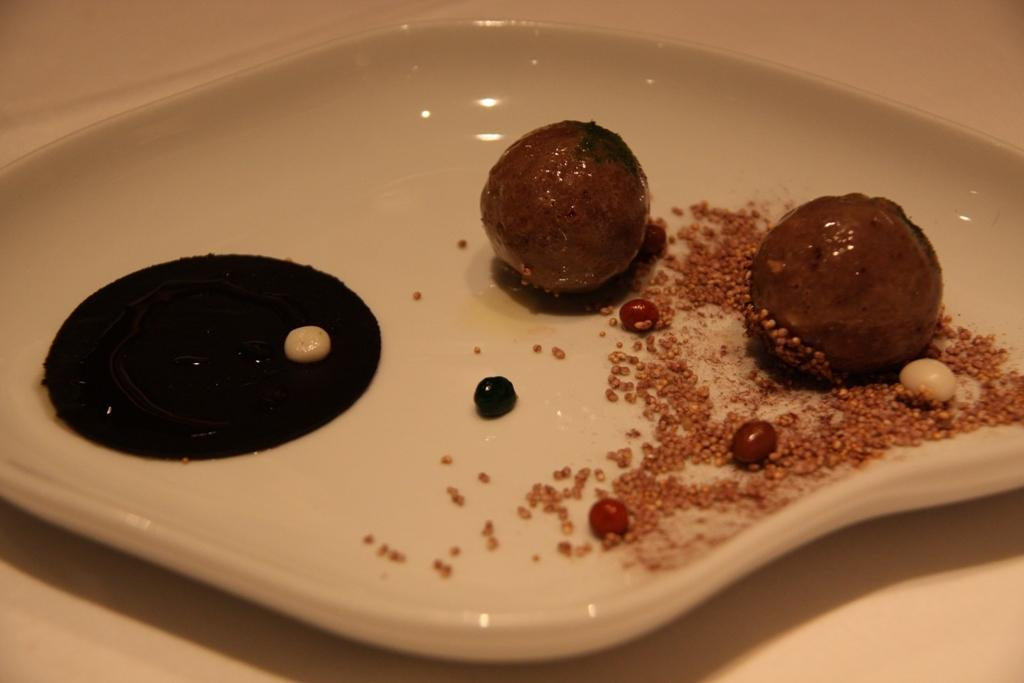What is the color of the plate in the image? The plate in the image is white. What types of food can be seen on the plate? There are two pieces of sweet and grains with garnish on the plate. What is the color of the cream in the image? The cream in the image is black. How does the field start to grow in the image? There is no field present in the image; it features a plate with food items and cream. What type of land is visible in the image? There is no land visible in the image; it features a plate with food items and cream. 